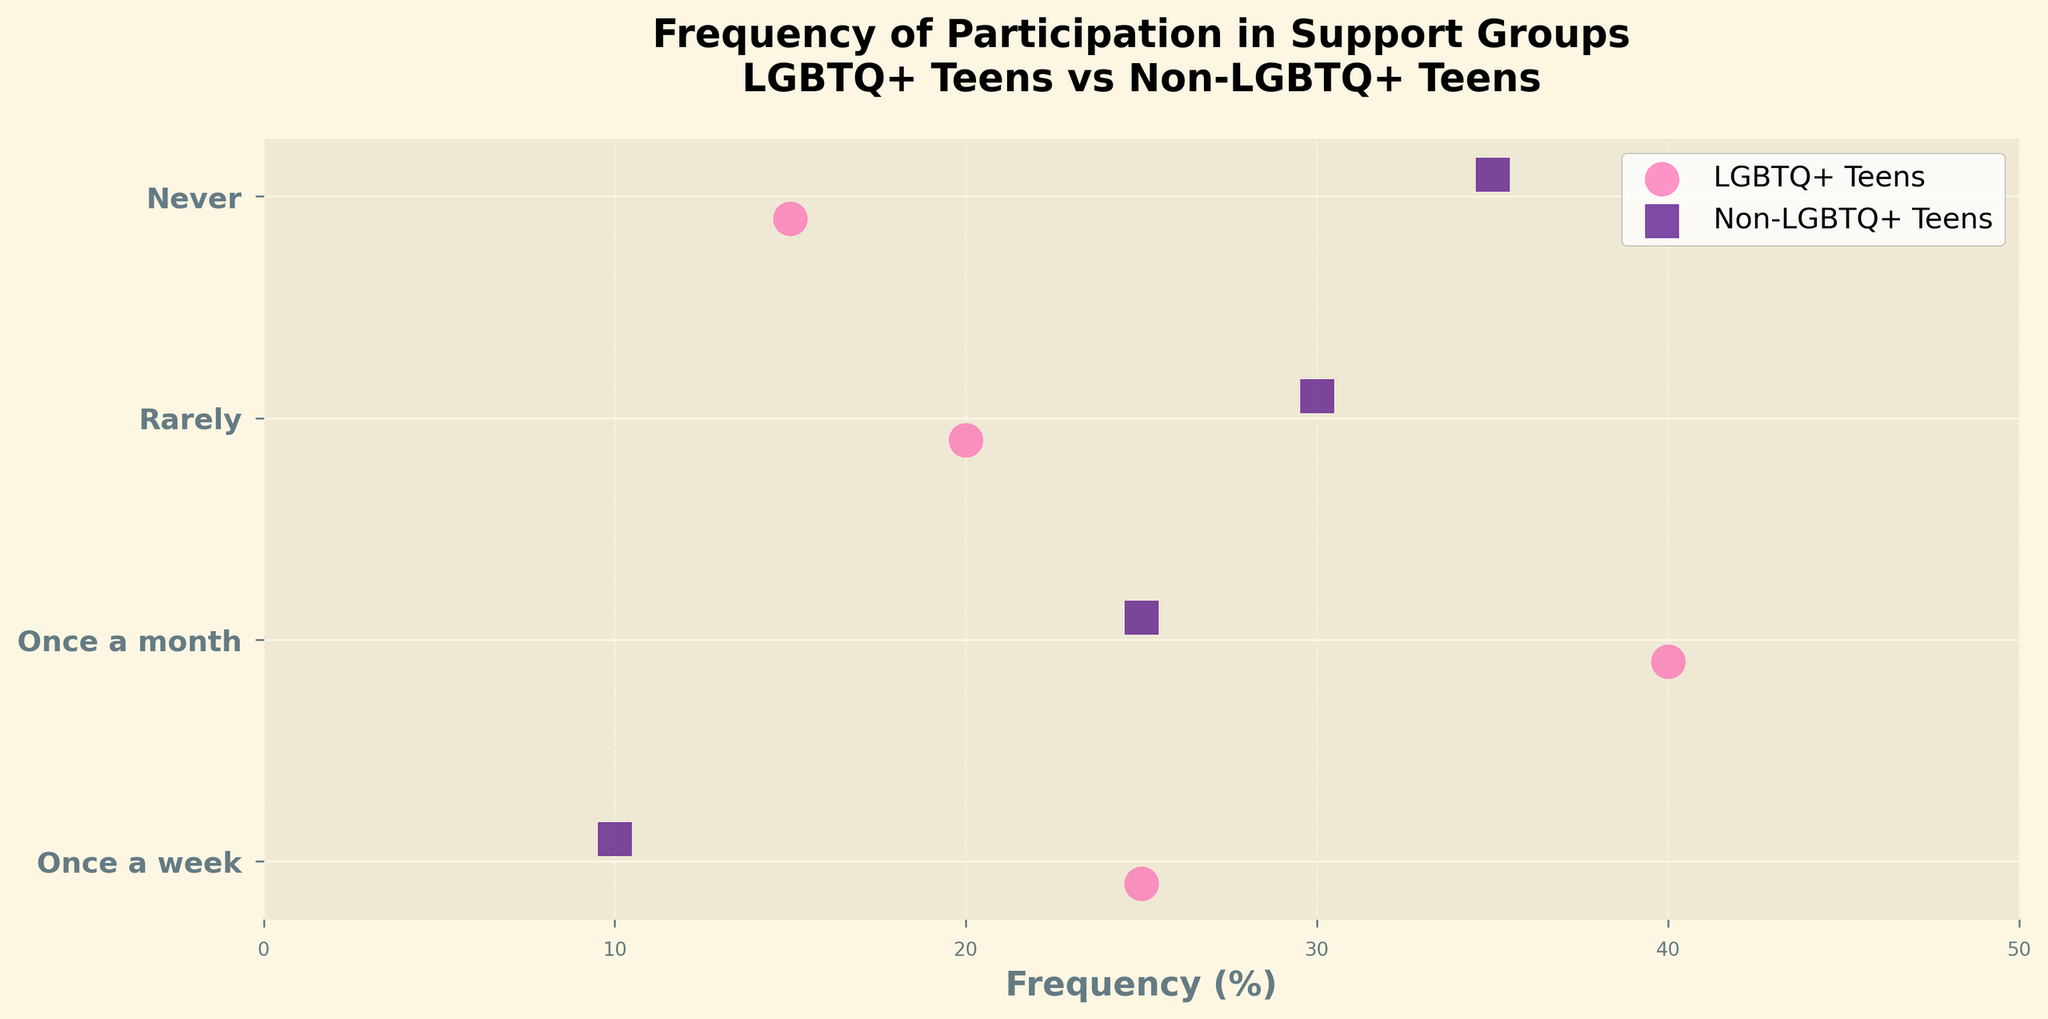What's the title of the figure? The title is usually at the top of the figure. It provides a concise summary of what the figure depicts. The title of the figure is "Frequency of Participation in Support Groups: LGBTQ+ Teens vs Non-LGBTQ+ Teens".
Answer: Frequency of Participation in Support Groups: LGBTQ+ Teens vs Non-LGBTQ+ Teens How many categories are shown on the y-axis? The y-axis lists the different levels of participation frequencies. The categories listed are "Once a week", "Once a month", "Rarely", and "Never".
Answer: 4 Which group has a higher participation rate for "Once a week"? To determine this, look at the dots for the category "Once a week" for both groups. The LGBTQ+ Teens dot is at 25%, while the Non-LGBTQ+ Teens dot is at 10%.
Answer: LGBTQ+ Teens What is the difference in participation rates between LGBTQ+ Teens and Non-LGBTQ+ Teens for "Once a month"? The participation rate can be found by subtracting the Non-LGBTQ+ Teens value from the LGBTQ+ Teens value. For "Once a month", it's 40% - 25%.
Answer: 15% Which frequency category has the smallest difference between LGBTQ+ Teens and Non-LGBTQ+ Teens? Compare the differences for all categories. For "Once a week", it's 15%, "Once a month" is 15%, "Rarely" is 10%, and "Never" is 20%. The smallest difference is for the "Rarely" category.
Answer: Rarely In which category do Non-LGBTQ+ Teens have the highest participation rate? For Non-LGBTQ+ Teens, check the value for each category. "Once a week" is 10%, "Once a month" is 25%, "Rarely" is 30%, and "Never" is 35%. The highest is at "Never".
Answer: Never What is the average participation rate for LGBTQ+ Teens across all categories? Add the rates for LGBTQ+ Teens (25% + 40% + 20% + 15%) and divide by the number of categories (4). 100% / 4 = 25%.
Answer: 25% How do the participation rates for "Rarely" compare between the groups? Look at the "Rarely" category for both groups. LGBTQ+ Teens are at 20% and Non-LGBTQ+ Teens are at 30%. Non-LGBTQ+ Teens have a higher rate.
Answer: Non-LGBTQ+ Teens have a higher rate by 10% What marker shapes are used for each group? The plot legend typically shows the different markers used. LGBTQ+ Teens are represented by circles (o), and Non-LGBTQ+ Teens by squares (s).
Answer: Circles for LGBTQ+ Teens, squares for Non-LGBTQ+ Teens If you were to average the participation rates for Non-LGBTQ+ Teens across all categories, what would that be? Sum the rates for Non-LGBTQ+ Teens (10% + 25% + 30% + 35%) and divide by the number of categories (4). 100% / 4 = 25%.
Answer: 25% 